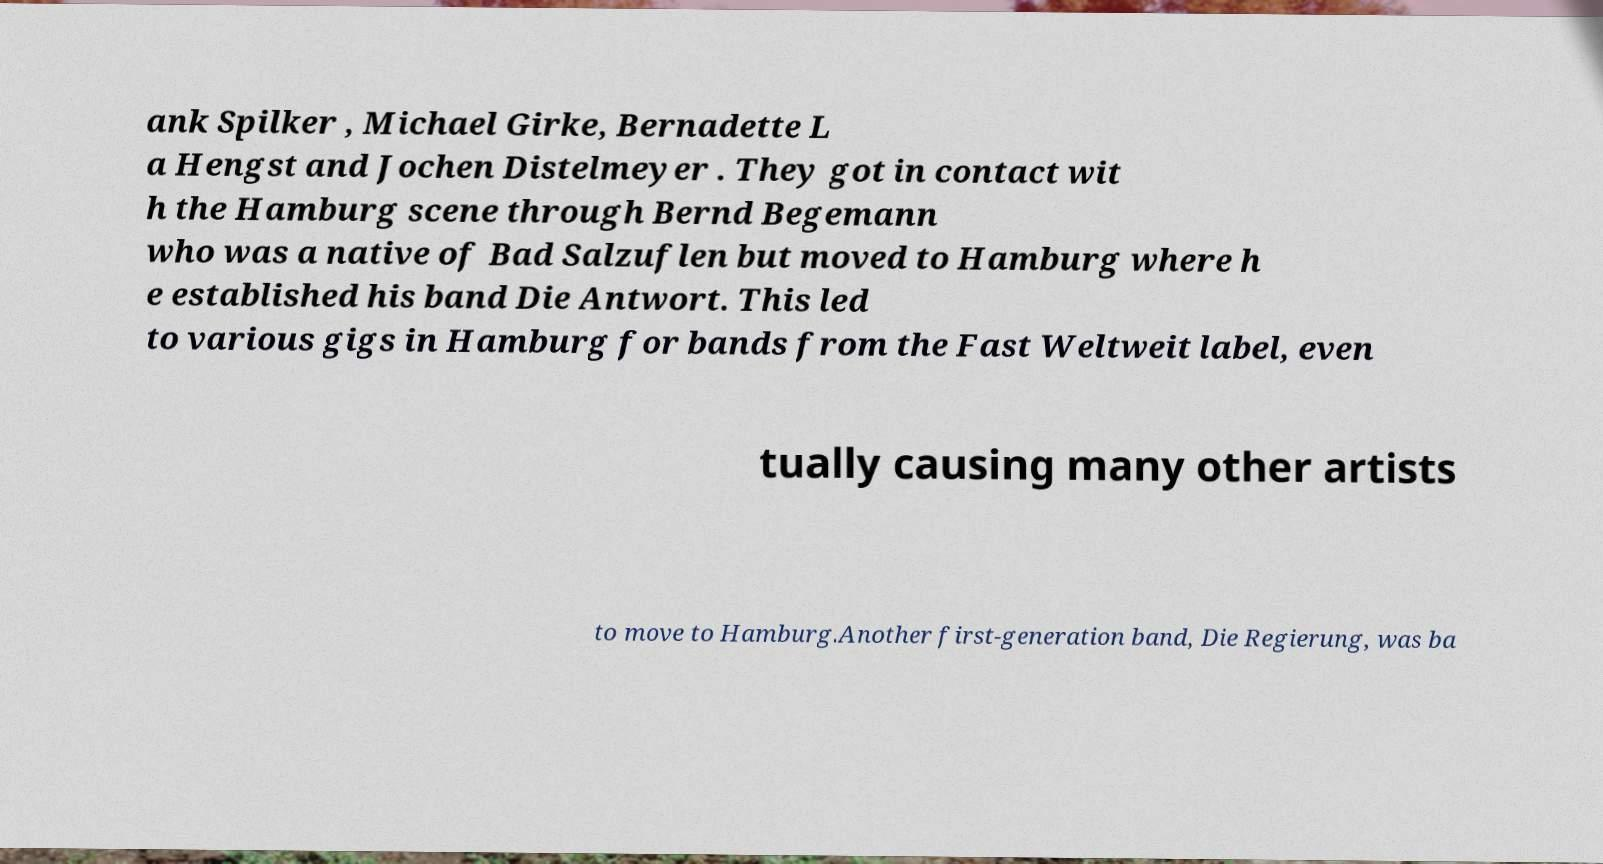There's text embedded in this image that I need extracted. Can you transcribe it verbatim? ank Spilker , Michael Girke, Bernadette L a Hengst and Jochen Distelmeyer . They got in contact wit h the Hamburg scene through Bernd Begemann who was a native of Bad Salzuflen but moved to Hamburg where h e established his band Die Antwort. This led to various gigs in Hamburg for bands from the Fast Weltweit label, even tually causing many other artists to move to Hamburg.Another first-generation band, Die Regierung, was ba 